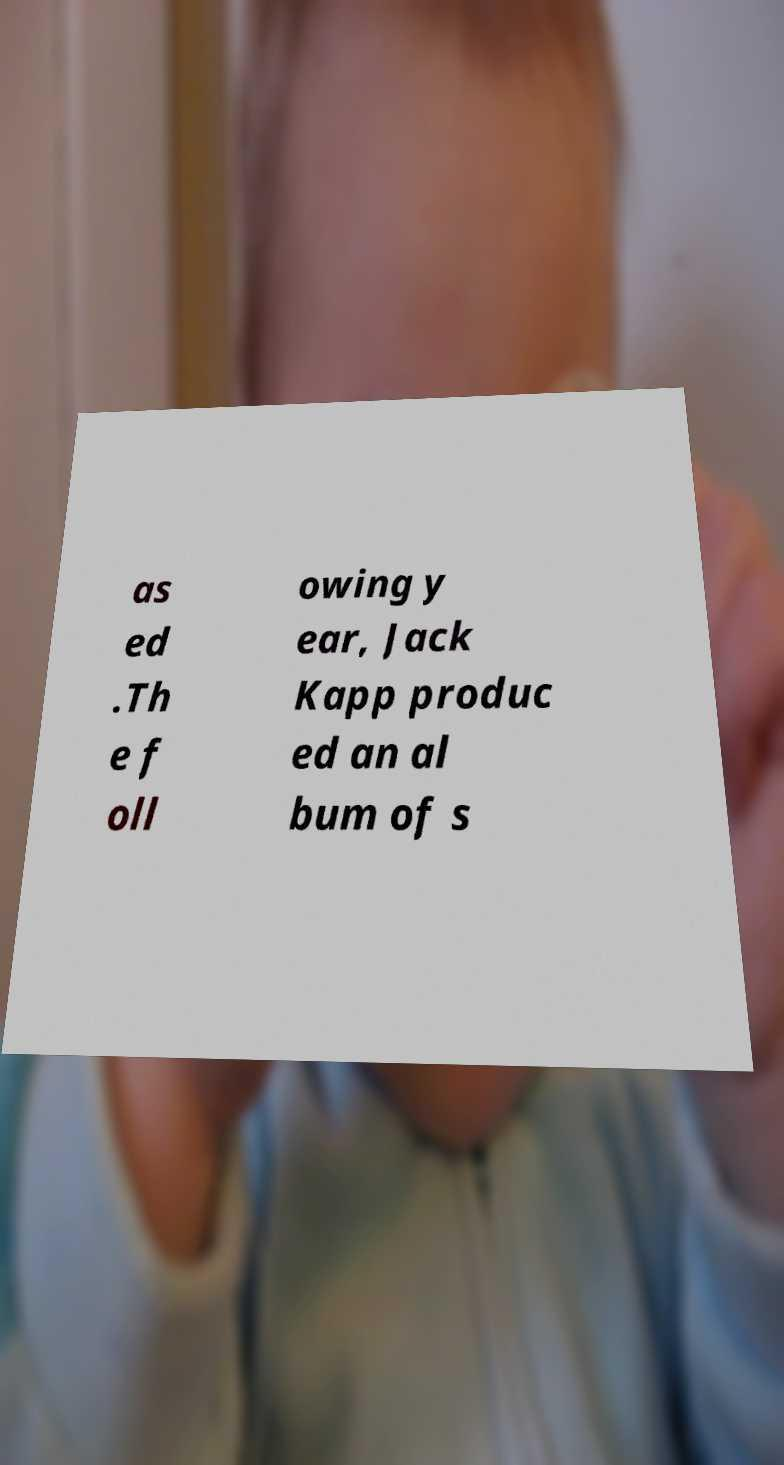There's text embedded in this image that I need extracted. Can you transcribe it verbatim? as ed .Th e f oll owing y ear, Jack Kapp produc ed an al bum of s 